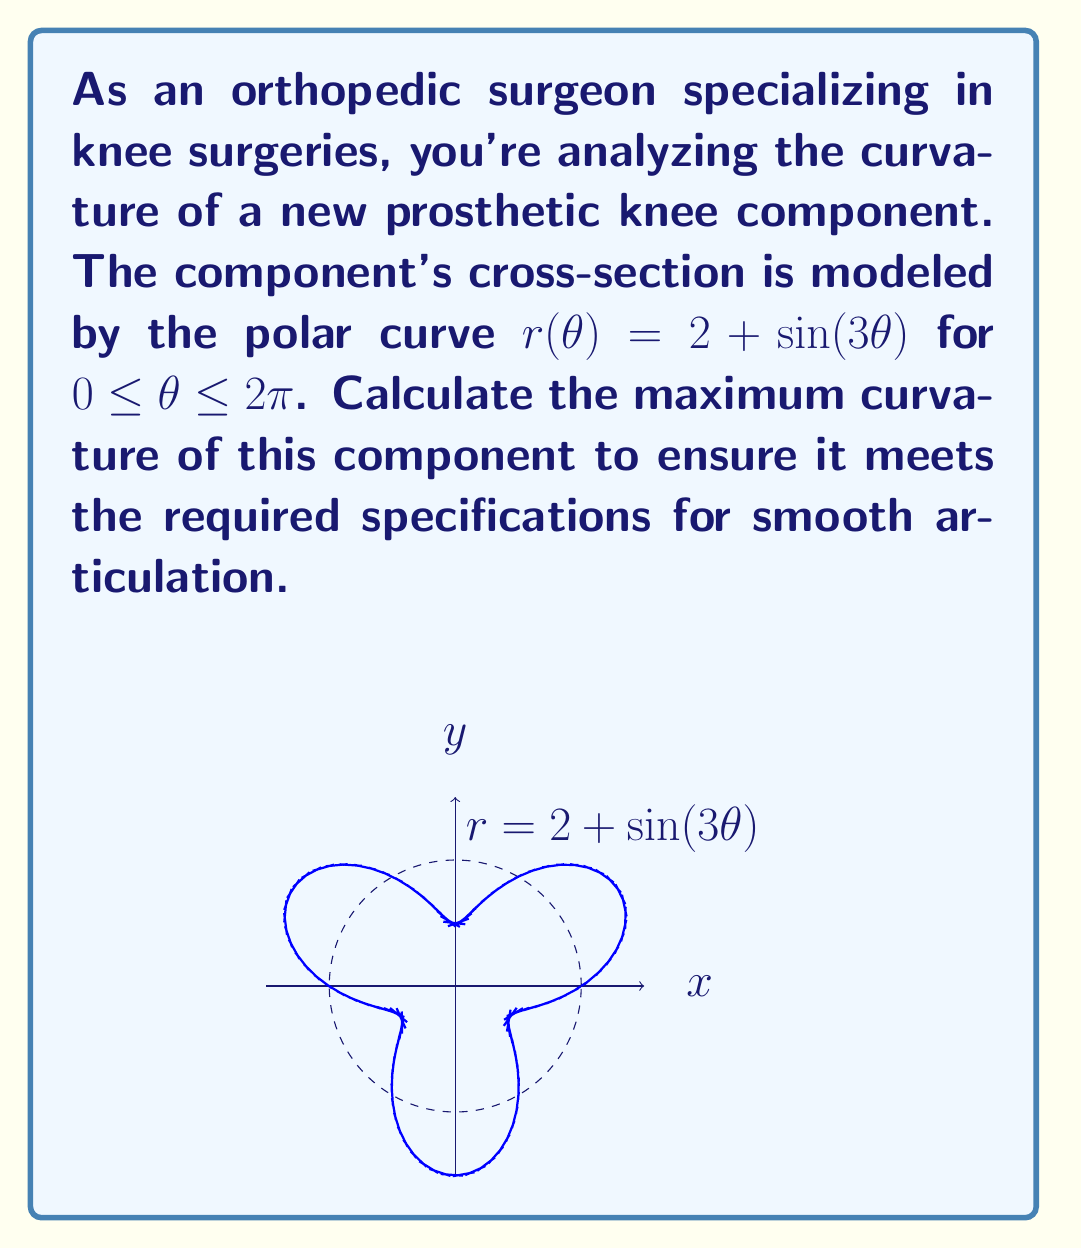Give your solution to this math problem. To find the maximum curvature, we'll follow these steps:

1) The curvature $\kappa$ in polar coordinates is given by:

   $$\kappa = \frac{|r^2 + 2(r')^2 - rr''|}{(r^2 + (r')^2)^{3/2}}$$

2) We need to find $r$, $r'$, and $r''$:
   $r = 2 + \sin(3\theta)$
   $r' = 3\cos(3\theta)$
   $r'' = -9\sin(3\theta)$

3) Substitute these into the curvature formula:

   $$\kappa = \frac{|(2 + \sin(3\theta))^2 + 2(3\cos(3\theta))^2 - (2 + \sin(3\theta))(-9\sin(3\theta))|}{((2 + \sin(3\theta))^2 + (3\cos(3\theta))^2)^{3/2}}$$

4) To find the maximum curvature, we need to differentiate $\kappa$ with respect to $\theta$ and set it to zero. However, this leads to a complex equation that's difficult to solve analytically.

5) Instead, we can use numerical methods or observe that the curvature will be maximum when $\sin(3\theta) = \pm 1$ and $\cos(3\theta) = 0$, which occurs at $\theta = \pi/6$ and $\theta = 5\pi/6$.

6) Evaluating at $\theta = \pi/6$:

   $$\kappa_{\text{max}} = \frac{|3^2 + 2(0)^2 - 3(-9)|}{(3^2 + 0^2)^{3/2}} = \frac{36}{27} = \frac{4}{3}$$

Therefore, the maximum curvature of the prosthetic knee component is $4/3$.
Answer: $\frac{4}{3}$ 